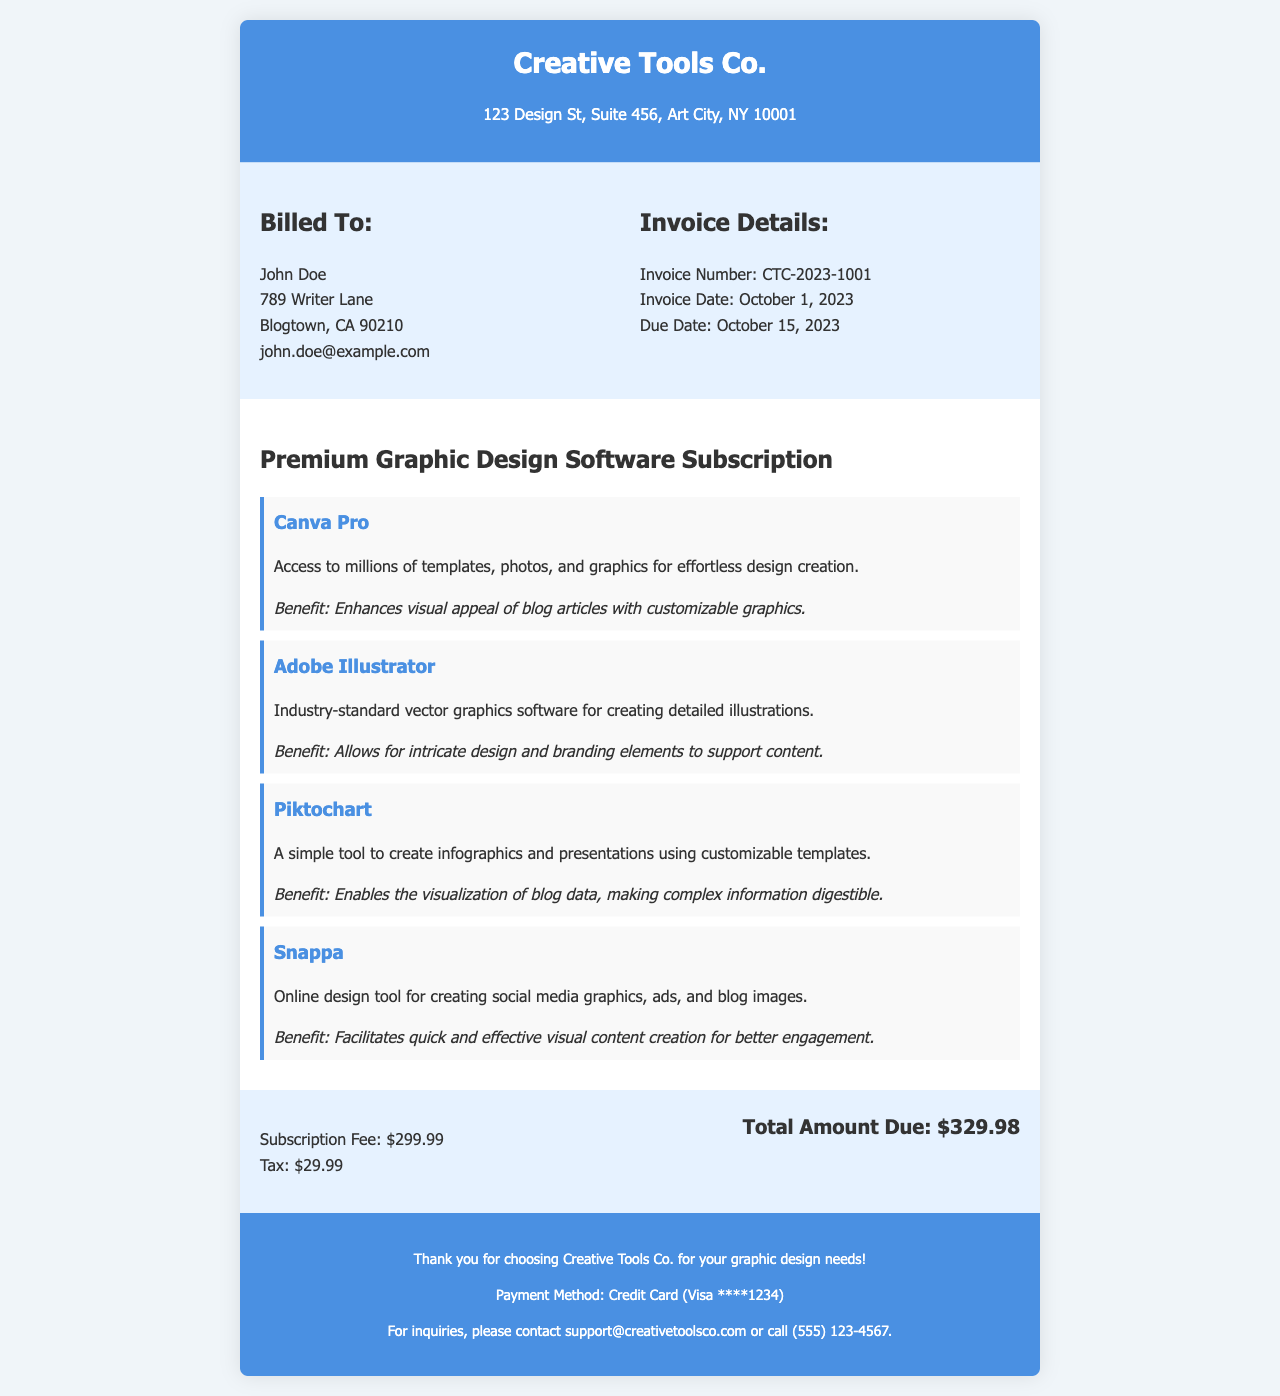What is the name of the company on the invoice? The name of the company is listed at the top of the invoice, which is Creative Tools Co.
Answer: Creative Tools Co What is the total amount due for the subscription? The total amount due is noted in the financial summary section of the document.
Answer: $329.98 When is the due date for the invoice? The due date is mentioned under the invoice details section of the document.
Answer: October 15, 2023 What type of subscription is detailed in this invoice? The type of subscription is provided in the subscription details section of the invoice.
Answer: Premium Graphic Design Software Subscription Which tool provides access to millions of templates and graphics? The tool with access to millions of templates is mentioned in the subscription details section of the document.
Answer: Canva Pro What is the benefit of using Snappa? The benefit of Snappa is described in the document's subscription details section, referring to its use for content creation.
Answer: Facilitates quick and effective visual content creation for better engagement How much is the subscription fee before tax? The subscription fee is outlined in the financial summary part of the document.
Answer: $299.99 Who is billed in this invoice? The billing information includes a name and address, which is presented in the billing info section of the document.
Answer: John Doe 